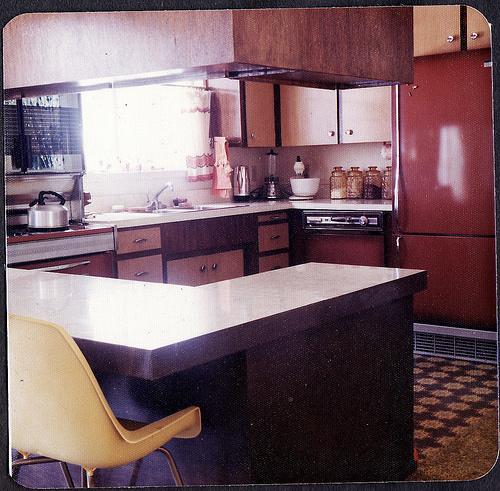Is the refrigerator white?
Concise answer only. No. Is there a full size fridge in the image?
Concise answer only. Yes. Is this a modern kitchen?
Answer briefly. No. Is the kitchen clean?
Quick response, please. Yes. Does the cabinet need to be refurbished?
Give a very brief answer. No. 